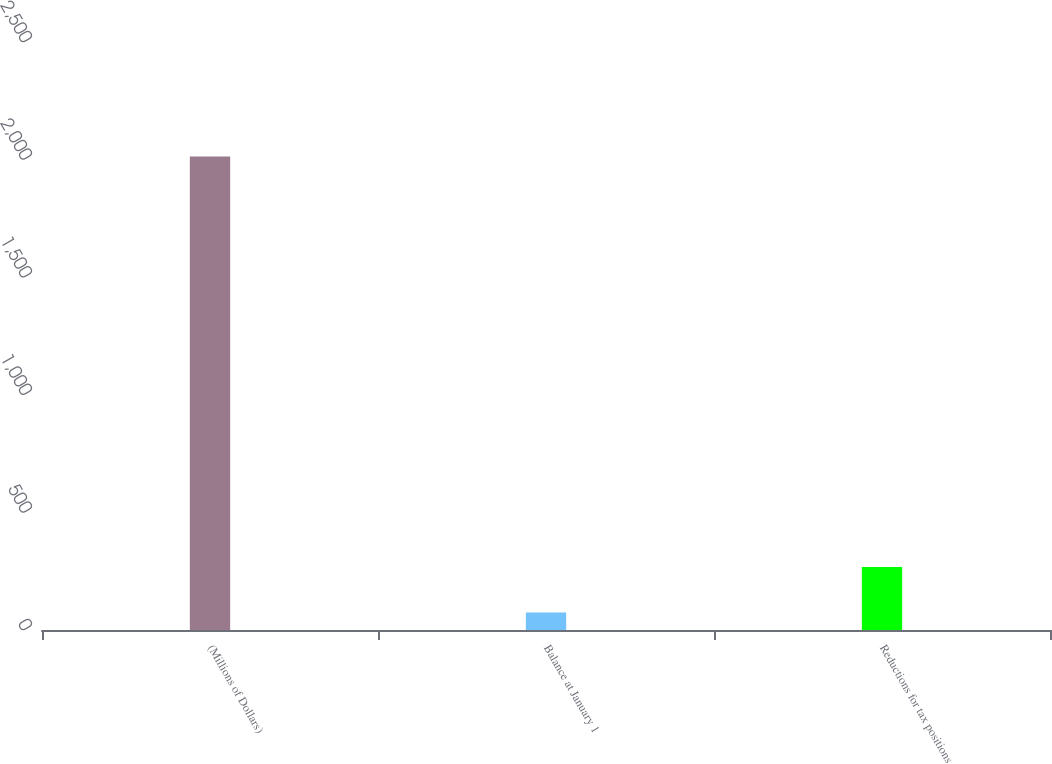<chart> <loc_0><loc_0><loc_500><loc_500><bar_chart><fcel>(Millions of Dollars)<fcel>Balance at January 1<fcel>Reductions for tax positions<nl><fcel>2013<fcel>74<fcel>267.9<nl></chart> 